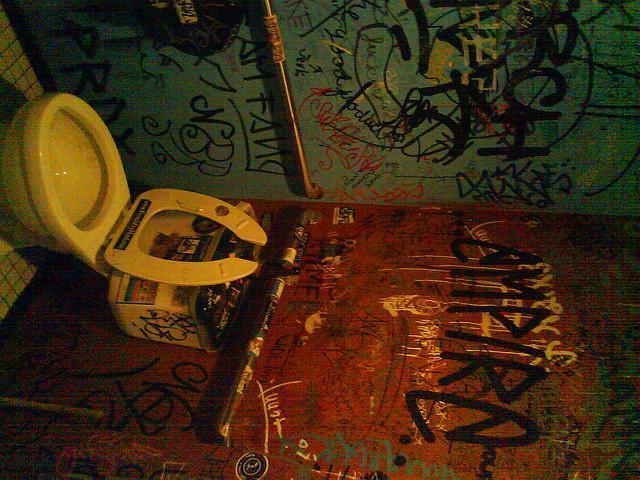How many toilets are visible?
Give a very brief answer. 1. How many zebras are there?
Give a very brief answer. 0. 